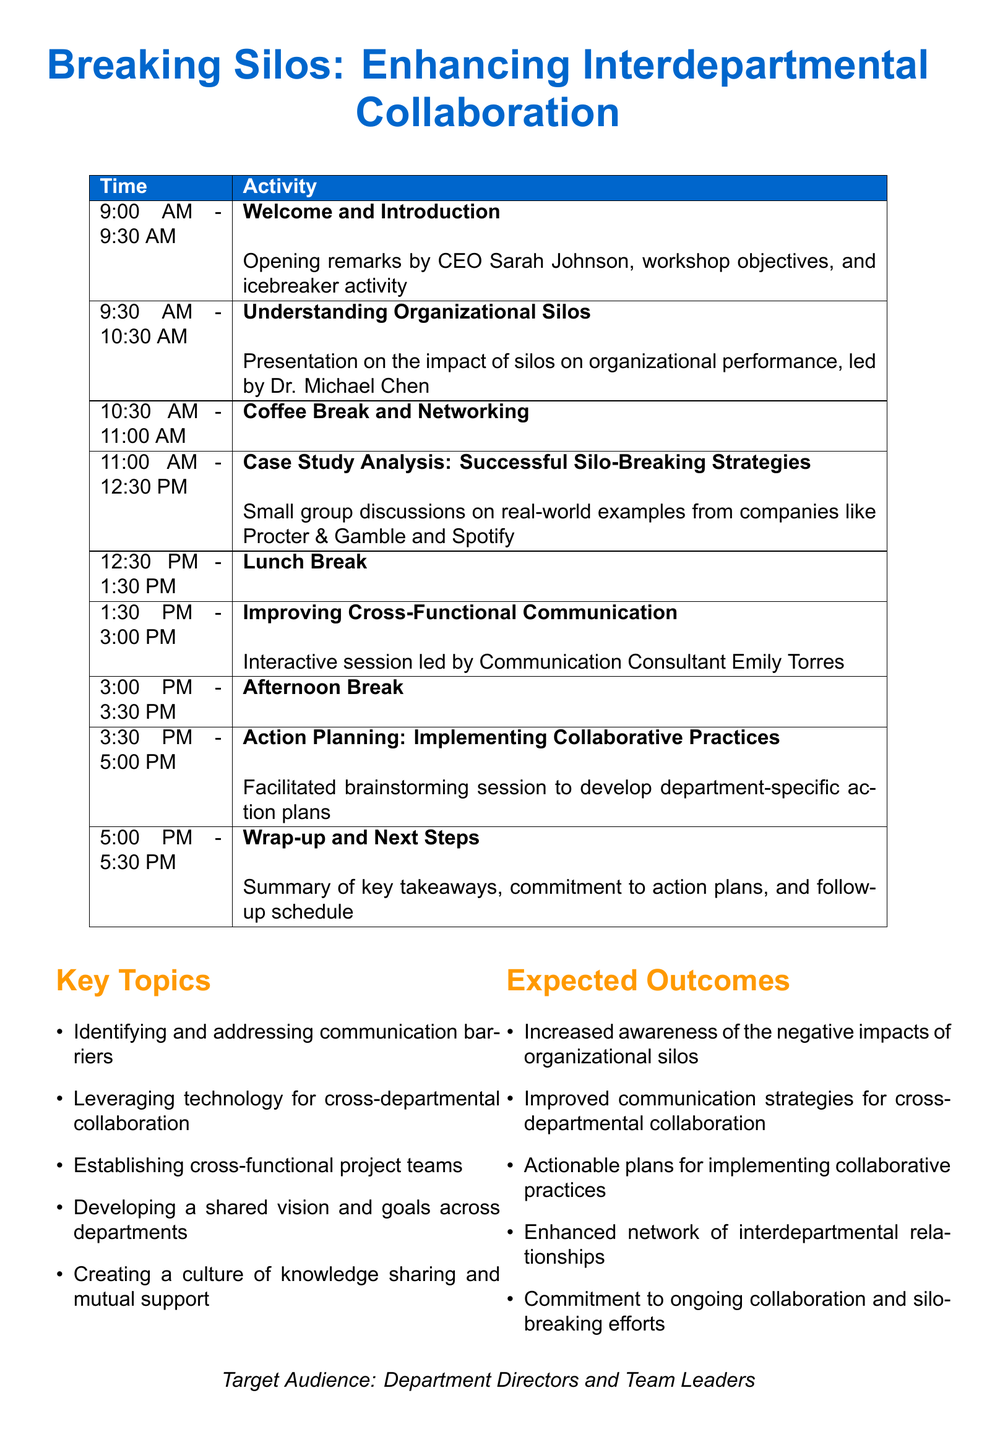What is the title of the workshop? The title of the workshop is mentioned at the top of the document.
Answer: Breaking Silos: Enhancing Interdepartmental Collaboration Who is leading the session on Understanding Organizational Silos? The document specifies that Dr. Michael Chen will lead this presentation.
Answer: Dr. Michael Chen What time is the Coffee Break scheduled? The agenda shows the Coffee Break is listed with a specific time.
Answer: 10:30 AM - 11:00 AM What is one of the expected outcomes of the workshop? The document lists several expected outcomes in a section.
Answer: Increased awareness of the negative impacts of organizational silos How long is the workshop scheduled to last? The document provides the total duration for the workshop.
Answer: Full-day (8 hours) Which company is mentioned as a case study for successful silo-breaking strategies? The agenda item references a specific company as a part of the case study.
Answer: Procter & Gamble What key topic addresses communication barriers? The document lists key topics, one of which is about communication barriers.
Answer: Identifying and addressing communication barriers When does the workshop wrap up? The agenda specifies the timing for the final session of the day.
Answer: 5:00 PM - 5:30 PM Who will facilitate the session on Improving Cross-Functional Communication? The agenda indicates the facilitator for this particular session.
Answer: Emily Torres 